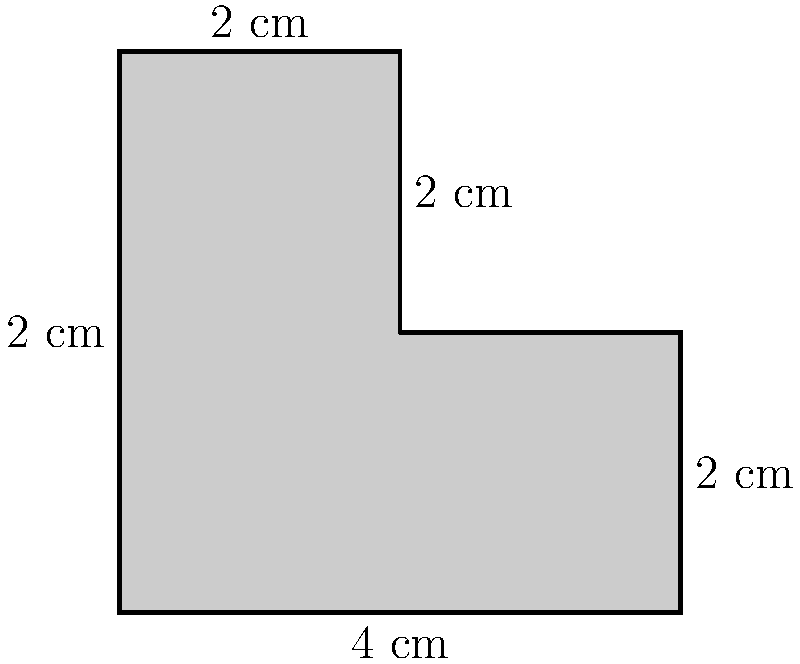As a loyal Kings fan, you're designing a custom jersey patch based on a simplified version of the team's crown logo. The patch is shaped like the polygon shown above. What is the perimeter of this Kings crown-inspired patch in centimeters? Let's break this down step-by-step:

1) The shape is made up of 6 line segments.

2) We need to add up the lengths of all these segments:

   - Bottom: 4 cm
   - Right side (bottom part): 2 cm
   - Right side (top part): 2 cm
   - Top: 2 cm
   - Left side (top part): 2 cm
   - Left side (bottom part): 2 cm

3) Adding these up:

   $4 + 2 + 2 + 2 + 2 + 2 = 14$ cm

Therefore, the perimeter of the Kings crown-inspired patch is 14 cm.
Answer: 14 cm 